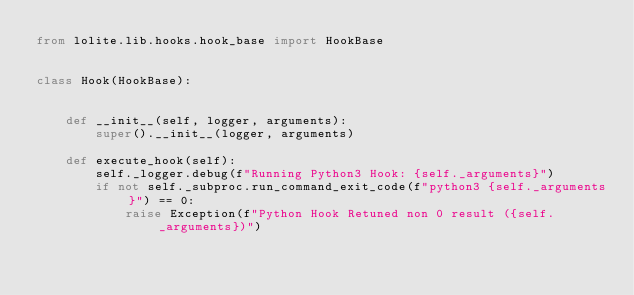<code> <loc_0><loc_0><loc_500><loc_500><_Python_>from lolite.lib.hooks.hook_base import HookBase


class Hook(HookBase):


    def __init__(self, logger, arguments):
        super().__init__(logger, arguments)

    def execute_hook(self):
        self._logger.debug(f"Running Python3 Hook: {self._arguments}")
        if not self._subproc.run_command_exit_code(f"python3 {self._arguments}") == 0:
            raise Exception(f"Python Hook Retuned non 0 result ({self._arguments})")
</code> 